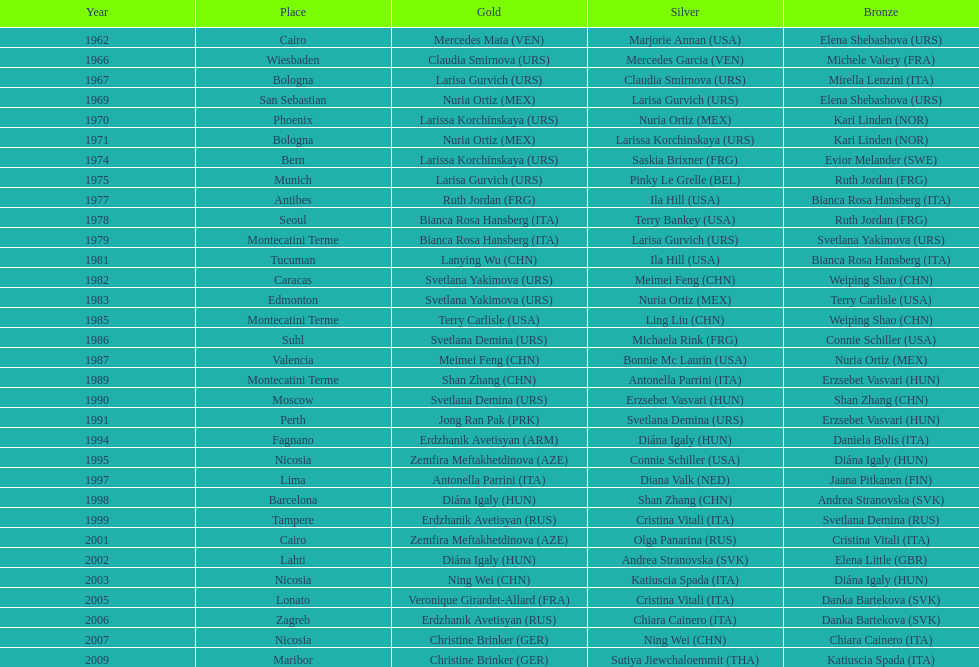In which country can you find the greatest amount of bronze medals? Italy. 